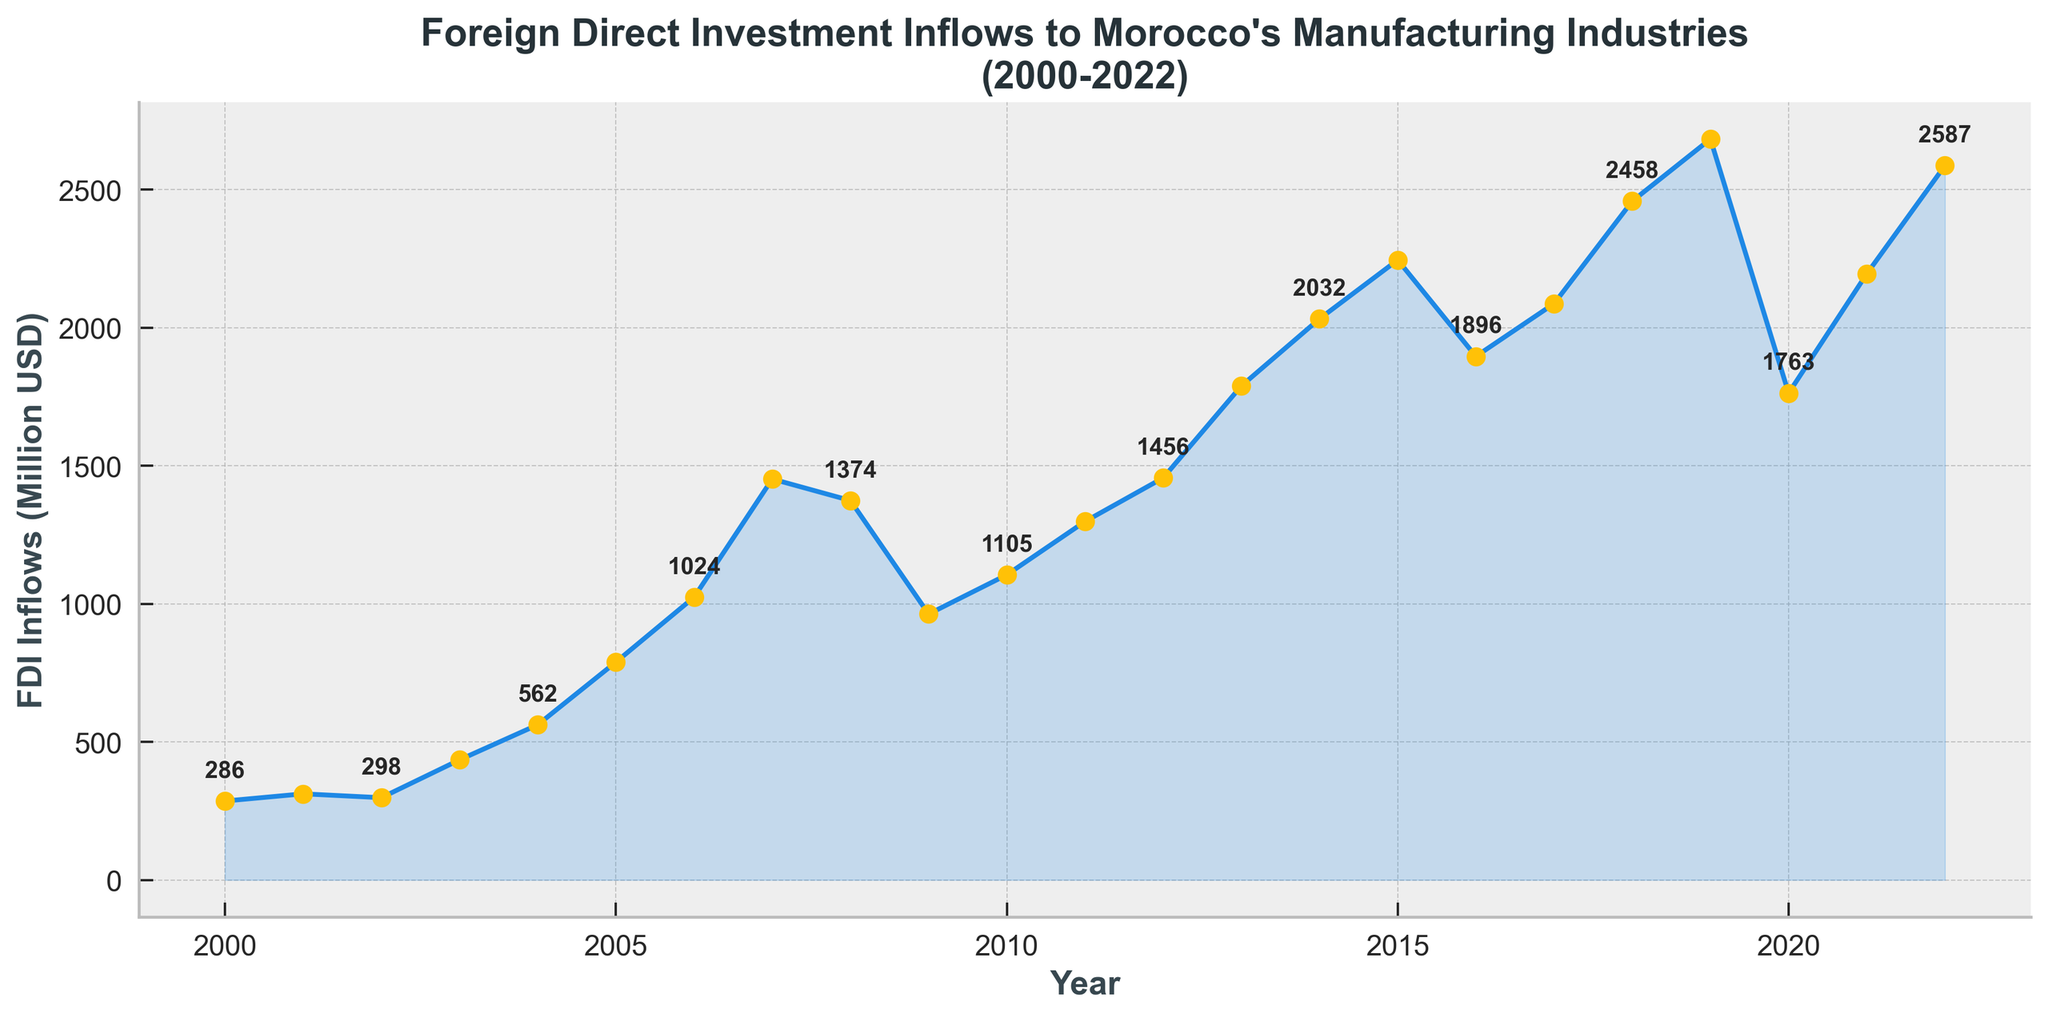What is the highest value of FDI inflows between 2000 and 2022? To find the highest value of FDI inflows, we scan through the data points on the line chart and identify the peak value. The peak occurs in the year 2019.
Answer: 2683 In which year did Morocco experience the lowest FDI inflow? We identify the lowest point on the line chart by visually comparing the heights of the data points. The lowest FDI inflow occured in the year 2000.
Answer: 2000 How much did FDI inflows increase from 2009 to 2010? To calculate the increase, subtract the value of FDI inflows in 2009 from the value in 2010. That is, 1105 (2010) - 963 (2009).
Answer: 142 Compare the FDI inflows in 2005 and 2006. Which year had higher inflows and by how much? We compare the data points for 2005 and 2006. FDI inflows in 2005 were 789 and in 2006 were 1024. 1024 - 789 gives the difference.
Answer: 2006 had higher inflows by 235 What is the average FDI inflow for the years 2020, 2021, and 2022? The average FDI inflow is calculated by summing the FDI values for 2020, 2021, and 2022, and dividing by the number of years: (1763 + 2195 + 2587) / 3.
Answer: 2181.67 From 2008 to 2009, did the FDI inflows increase or decrease and by what percentage? To find out whether the FDI inflows increased or decreased, we calculate the difference from 2008 to 2009. The FDI inflows decreased from 1374 to 963. Percentage change = [(1374 - 963) / 1374] * 100.
Answer: Decrease by 29.9% How many times did the FDI inflows exceed 2000 million USD? We count the number of data points above the 2000 million USD mark by looking at the chart. The years above 2000 million USD are 2014, 2015, 2018, 2019, and 2022.
Answer: 5 times What was the trend in FDI inflows from 2000 to 2014? We identify the overall trend by comparing the starting value in 2000 and the ending value in 2014 and visually assessing the pattern on the chart. The inflow gradually increases over time.
Answer: Increasing trend Which year experienced a more significant dip than the previous year: 2016 or 2020? We compare drops by looking at the percentage decrease from the previous years to 2016 and 2020 respectively. The drop from 2015 to 2016 is (2245 - 1896) / 2245 ≈ 15.51%, and from 2019 to 2020 is (2683 - 1763) / 2683 ≈ 34.31%.
Answer: 2020 